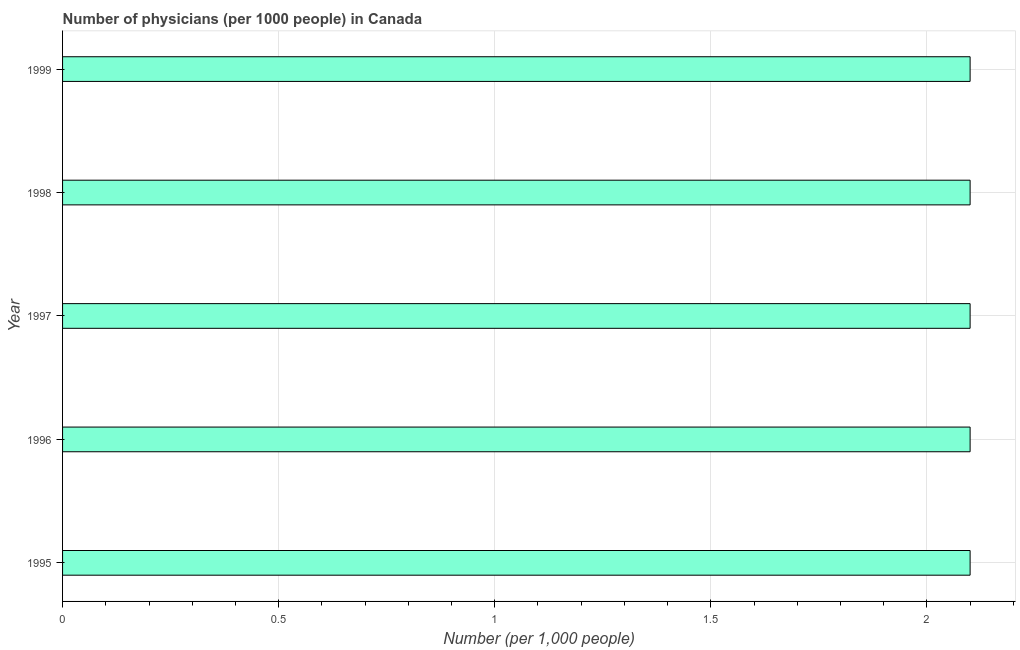What is the title of the graph?
Your answer should be very brief. Number of physicians (per 1000 people) in Canada. What is the label or title of the X-axis?
Offer a terse response. Number (per 1,0 people). What is the number of physicians in 1995?
Give a very brief answer. 2.1. In which year was the number of physicians minimum?
Your response must be concise. 1995. What is the sum of the number of physicians?
Give a very brief answer. 10.5. What is the difference between the number of physicians in 1995 and 1998?
Offer a terse response. 0. What is the average number of physicians per year?
Make the answer very short. 2.1. Do a majority of the years between 1997 and 1996 (inclusive) have number of physicians greater than 0.5 ?
Your answer should be compact. No. Is the difference between the number of physicians in 1997 and 1998 greater than the difference between any two years?
Your answer should be very brief. Yes. What is the difference between the highest and the second highest number of physicians?
Give a very brief answer. 0. What is the difference between the highest and the lowest number of physicians?
Ensure brevity in your answer.  0. In how many years, is the number of physicians greater than the average number of physicians taken over all years?
Your answer should be very brief. 0. Are all the bars in the graph horizontal?
Your answer should be very brief. Yes. How many years are there in the graph?
Ensure brevity in your answer.  5. What is the difference between two consecutive major ticks on the X-axis?
Your answer should be compact. 0.5. Are the values on the major ticks of X-axis written in scientific E-notation?
Provide a succinct answer. No. What is the Number (per 1,000 people) in 1997?
Provide a succinct answer. 2.1. What is the Number (per 1,000 people) in 1998?
Provide a succinct answer. 2.1. What is the difference between the Number (per 1,000 people) in 1995 and 1996?
Offer a terse response. 0. What is the difference between the Number (per 1,000 people) in 1995 and 1998?
Provide a short and direct response. 0. What is the difference between the Number (per 1,000 people) in 1996 and 1997?
Offer a very short reply. 0. What is the difference between the Number (per 1,000 people) in 1996 and 1999?
Make the answer very short. 0. What is the difference between the Number (per 1,000 people) in 1997 and 1998?
Make the answer very short. 0. What is the ratio of the Number (per 1,000 people) in 1995 to that in 1999?
Ensure brevity in your answer.  1. What is the ratio of the Number (per 1,000 people) in 1997 to that in 1998?
Offer a very short reply. 1. 